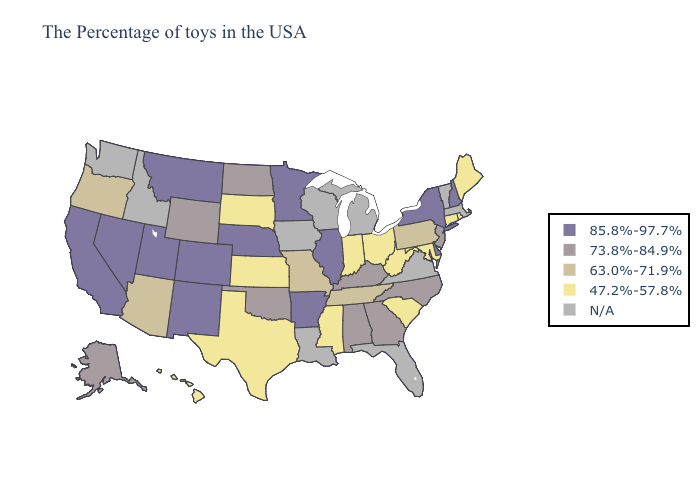What is the lowest value in the South?
Give a very brief answer. 47.2%-57.8%. What is the lowest value in states that border North Carolina?
Give a very brief answer. 47.2%-57.8%. Name the states that have a value in the range 85.8%-97.7%?
Write a very short answer. New Hampshire, New York, Delaware, Illinois, Arkansas, Minnesota, Nebraska, Colorado, New Mexico, Utah, Montana, Nevada, California. Does Arkansas have the lowest value in the USA?
Quick response, please. No. Does Arkansas have the lowest value in the USA?
Concise answer only. No. What is the lowest value in states that border Mississippi?
Keep it brief. 63.0%-71.9%. Which states hav the highest value in the South?
Short answer required. Delaware, Arkansas. Name the states that have a value in the range 73.8%-84.9%?
Short answer required. New Jersey, North Carolina, Georgia, Kentucky, Alabama, Oklahoma, North Dakota, Wyoming, Alaska. What is the value of Arkansas?
Concise answer only. 85.8%-97.7%. Name the states that have a value in the range 47.2%-57.8%?
Answer briefly. Maine, Rhode Island, Connecticut, Maryland, South Carolina, West Virginia, Ohio, Indiana, Mississippi, Kansas, Texas, South Dakota, Hawaii. Is the legend a continuous bar?
Answer briefly. No. Among the states that border New York , which have the lowest value?
Be succinct. Connecticut. What is the value of North Dakota?
Write a very short answer. 73.8%-84.9%. Name the states that have a value in the range N/A?
Write a very short answer. Massachusetts, Vermont, Virginia, Florida, Michigan, Wisconsin, Louisiana, Iowa, Idaho, Washington. 